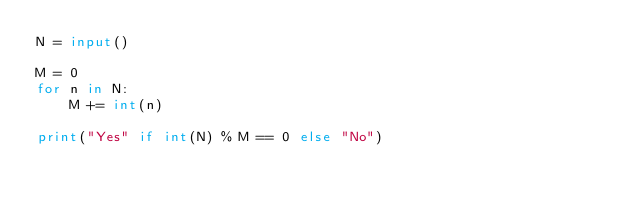<code> <loc_0><loc_0><loc_500><loc_500><_Python_>N = input()

M = 0
for n in N:
    M += int(n)

print("Yes" if int(N) % M == 0 else "No")
</code> 